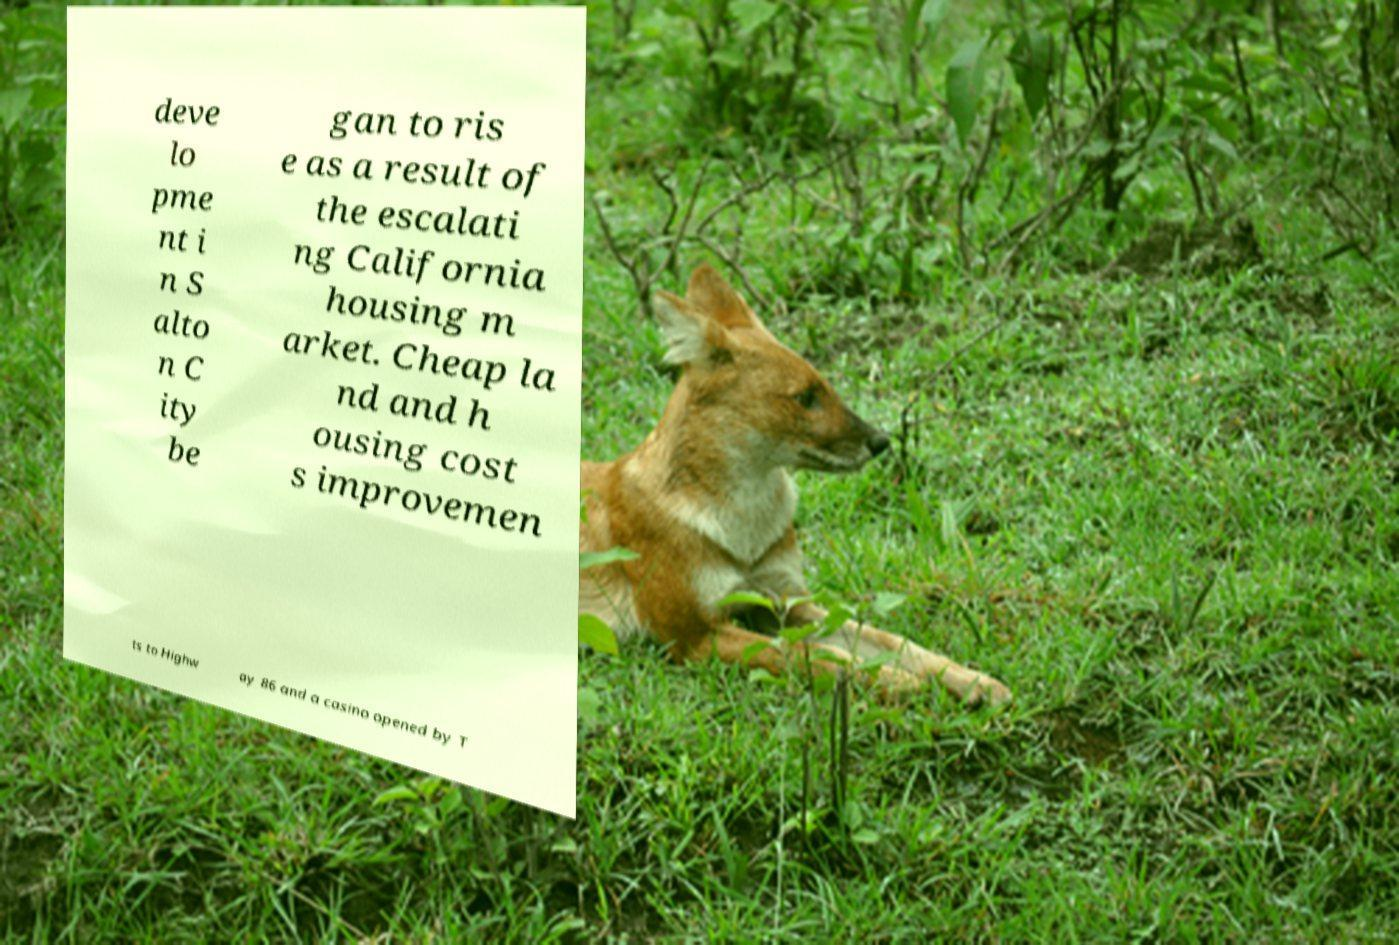What messages or text are displayed in this image? I need them in a readable, typed format. deve lo pme nt i n S alto n C ity be gan to ris e as a result of the escalati ng California housing m arket. Cheap la nd and h ousing cost s improvemen ts to Highw ay 86 and a casino opened by T 